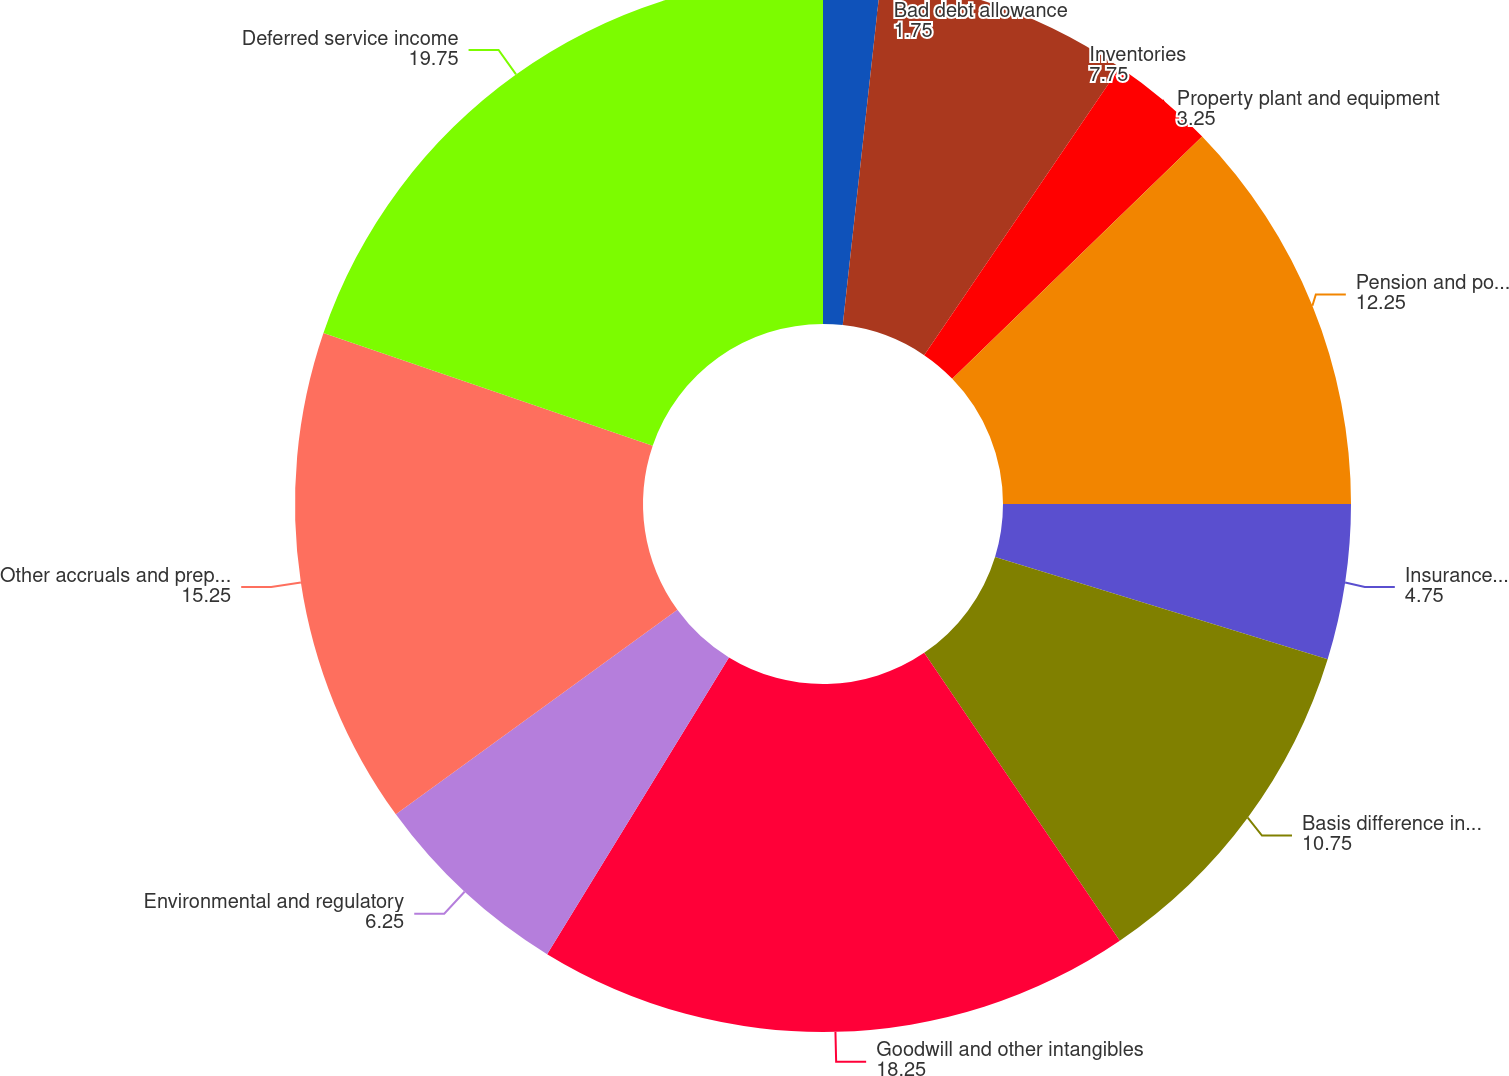<chart> <loc_0><loc_0><loc_500><loc_500><pie_chart><fcel>Bad debt allowance<fcel>Inventories<fcel>Property plant and equipment<fcel>Pension and postretirement<fcel>Insurance including<fcel>Basis difference in LYONs<fcel>Goodwill and other intangibles<fcel>Environmental and regulatory<fcel>Other accruals and prepayments<fcel>Deferred service income<nl><fcel>1.75%<fcel>7.75%<fcel>3.25%<fcel>12.25%<fcel>4.75%<fcel>10.75%<fcel>18.25%<fcel>6.25%<fcel>15.25%<fcel>19.75%<nl></chart> 